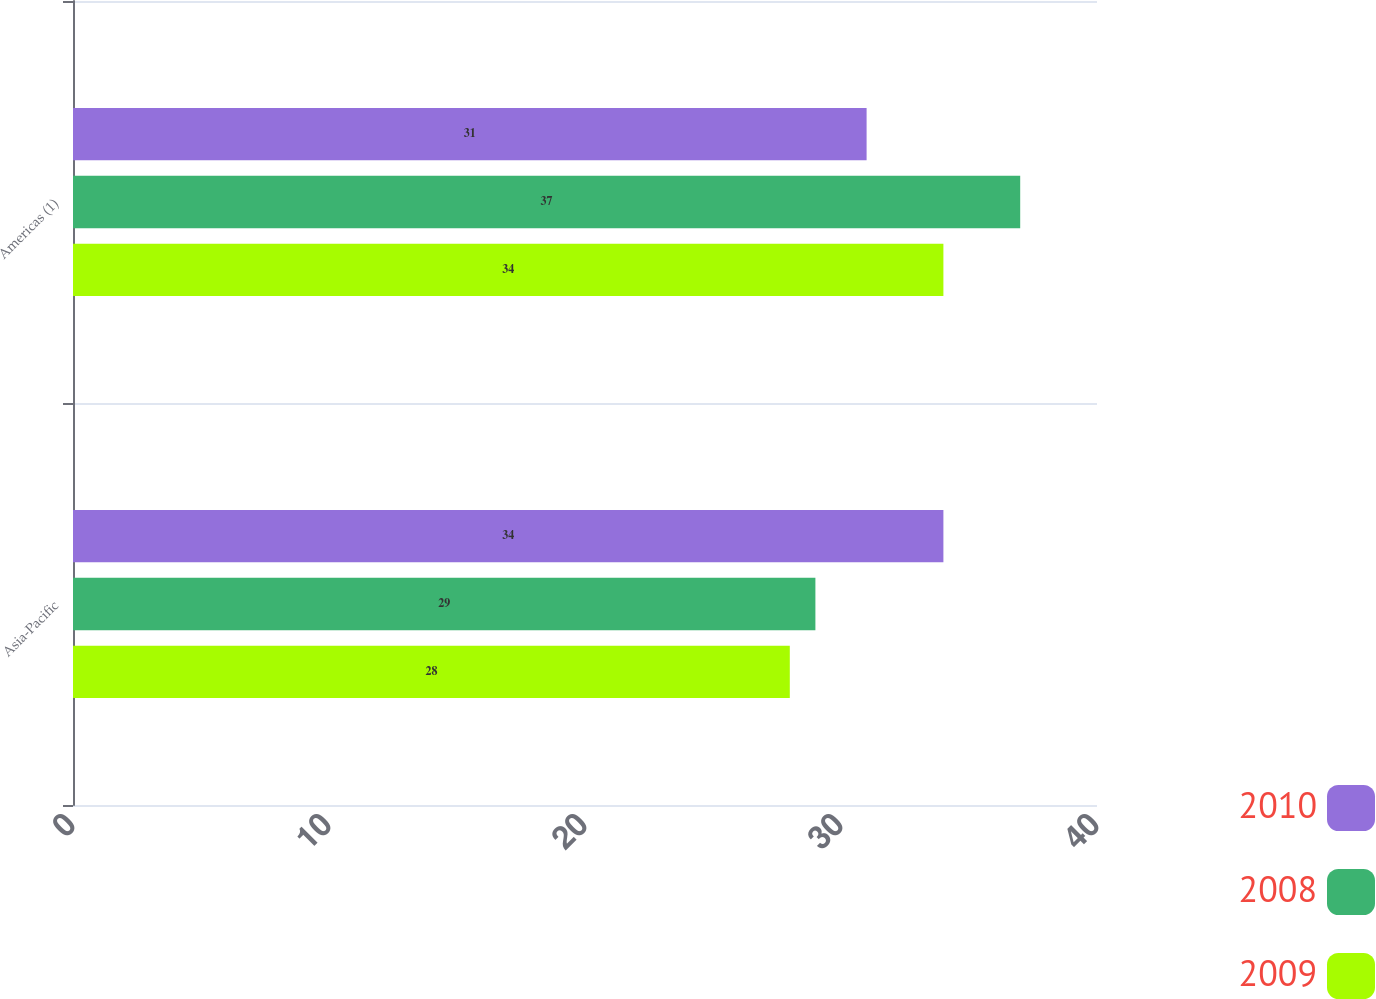<chart> <loc_0><loc_0><loc_500><loc_500><stacked_bar_chart><ecel><fcel>Asia-Pacific<fcel>Americas (1)<nl><fcel>2010<fcel>34<fcel>31<nl><fcel>2008<fcel>29<fcel>37<nl><fcel>2009<fcel>28<fcel>34<nl></chart> 